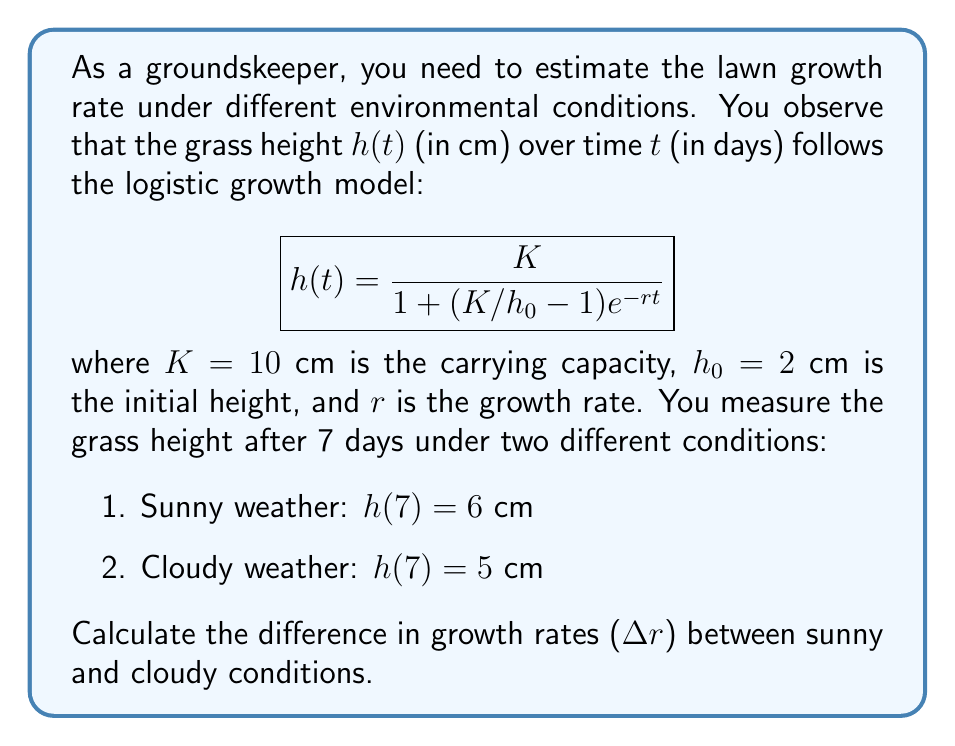Could you help me with this problem? To solve this problem, we need to follow these steps:

1. Use the given logistic growth model to set up equations for both sunny and cloudy conditions.
2. Solve for the growth rate $r$ in each case.
3. Calculate the difference between the two growth rates.

Step 1: Set up equations

For sunny weather:
$$6 = \frac{10}{1 + (10/2 - 1)e^{-7r_s}}$$

For cloudy weather:
$$5 = \frac{10}{1 + (10/2 - 1)e^{-7r_c}}$$

Step 2: Solve for growth rates

For sunny weather:
$$6 = \frac{10}{1 + 4e^{-7r_s}}$$
$$\frac{10}{6} = 1 + 4e^{-7r_s}$$
$$\frac{2}{3} = 4e^{-7r_s}$$
$$\ln(\frac{2}{3}) = \ln(4) - 7r_s$$
$$r_s = \frac{\ln(4) - \ln(\frac{2}{3})}{7} \approx 0.2231$$

For cloudy weather:
$$5 = \frac{10}{1 + 4e^{-7r_c}}$$
$$2 = 1 + 4e^{-7r_c}$$
$$1 = 4e^{-7r_c}$$
$$\ln(1) = \ln(4) - 7r_c$$
$$r_c = \frac{\ln(4)}{7} \approx 0.1980$$

Step 3: Calculate the difference in growth rates

$$\Delta r = r_s - r_c = 0.2231 - 0.1980 \approx 0.0251$$
Answer: $\Delta r \approx 0.0251$ day$^{-1}$ 